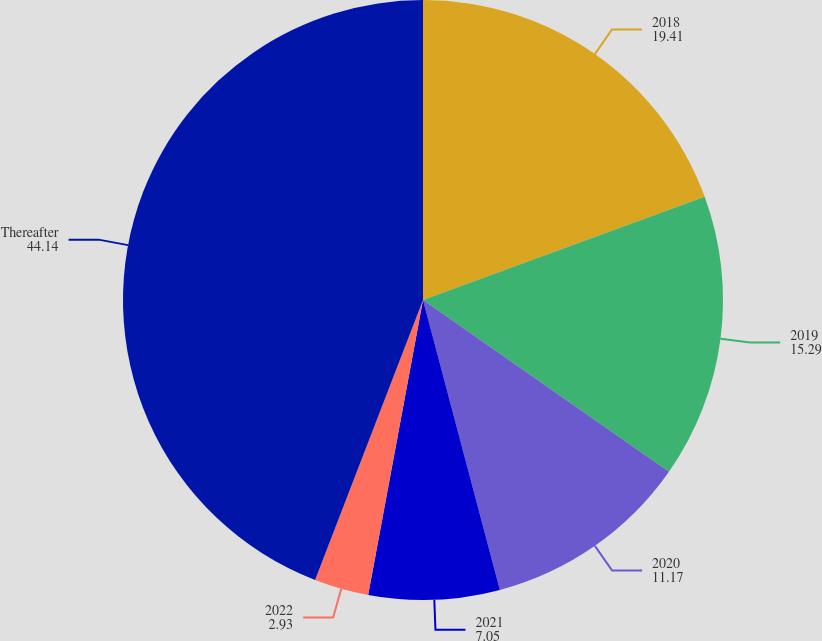Convert chart. <chart><loc_0><loc_0><loc_500><loc_500><pie_chart><fcel>2018<fcel>2019<fcel>2020<fcel>2021<fcel>2022<fcel>Thereafter<nl><fcel>19.41%<fcel>15.29%<fcel>11.17%<fcel>7.05%<fcel>2.93%<fcel>44.14%<nl></chart> 